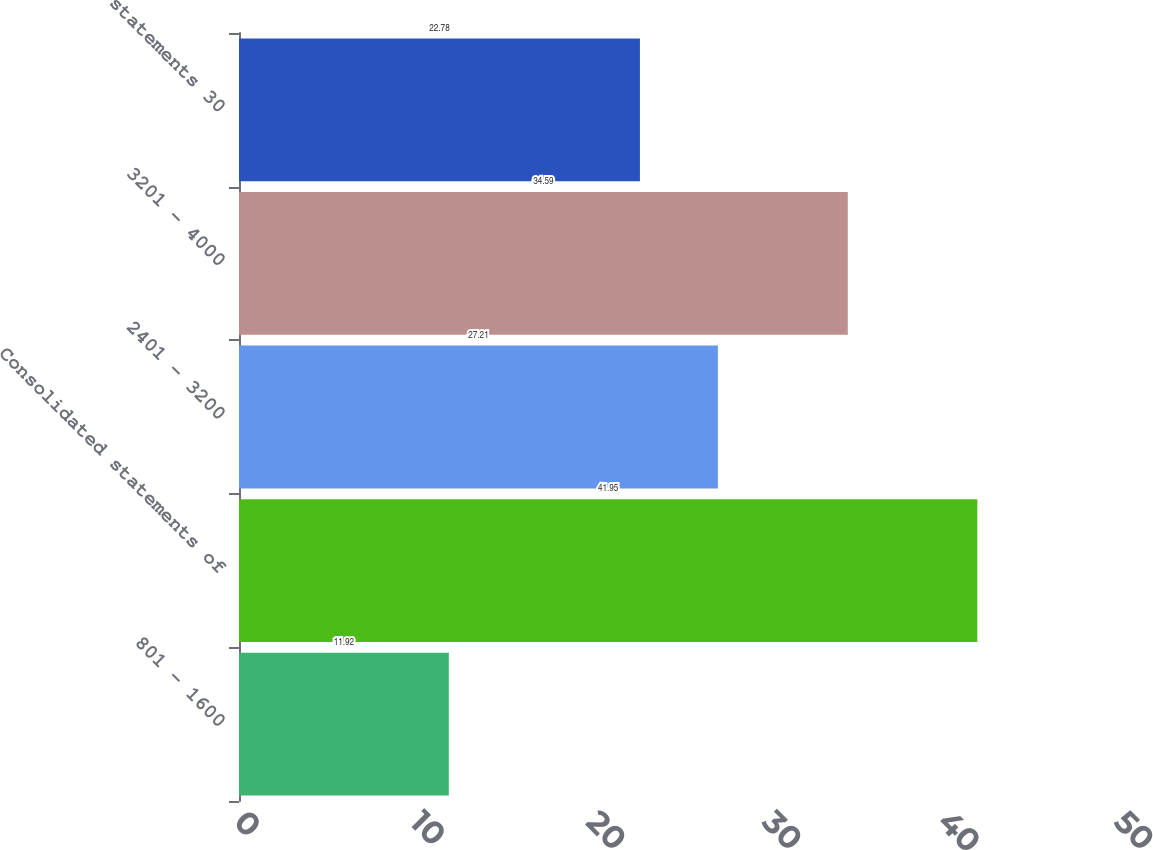Convert chart. <chart><loc_0><loc_0><loc_500><loc_500><bar_chart><fcel>801 - 1600<fcel>Consolidated statements of<fcel>2401 - 3200<fcel>3201 - 4000<fcel>statements 30<nl><fcel>11.92<fcel>41.95<fcel>27.21<fcel>34.59<fcel>22.78<nl></chart> 